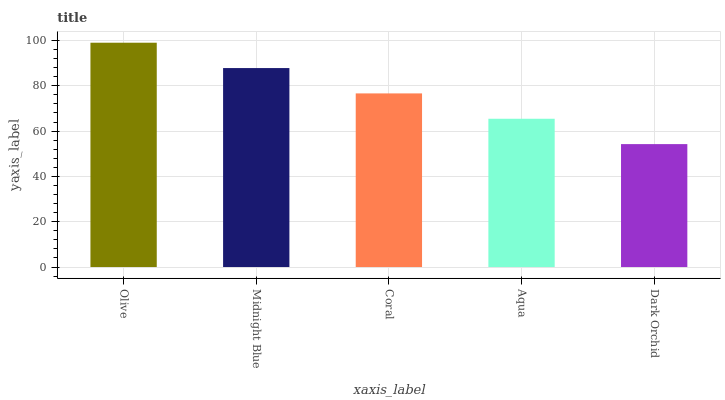Is Dark Orchid the minimum?
Answer yes or no. Yes. Is Olive the maximum?
Answer yes or no. Yes. Is Midnight Blue the minimum?
Answer yes or no. No. Is Midnight Blue the maximum?
Answer yes or no. No. Is Olive greater than Midnight Blue?
Answer yes or no. Yes. Is Midnight Blue less than Olive?
Answer yes or no. Yes. Is Midnight Blue greater than Olive?
Answer yes or no. No. Is Olive less than Midnight Blue?
Answer yes or no. No. Is Coral the high median?
Answer yes or no. Yes. Is Coral the low median?
Answer yes or no. Yes. Is Aqua the high median?
Answer yes or no. No. Is Dark Orchid the low median?
Answer yes or no. No. 